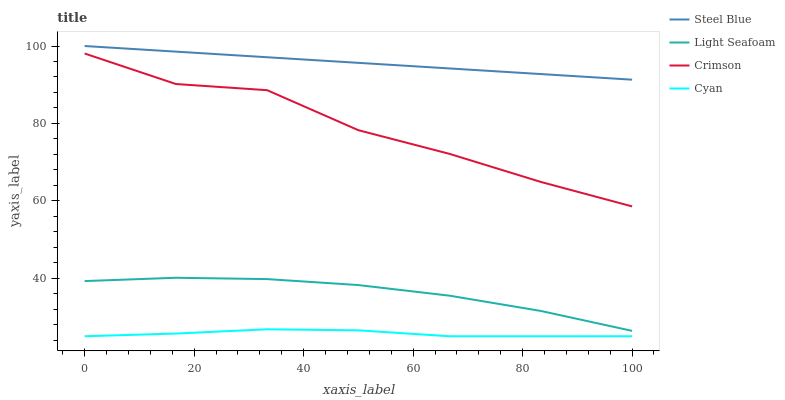Does Cyan have the minimum area under the curve?
Answer yes or no. Yes. Does Steel Blue have the maximum area under the curve?
Answer yes or no. Yes. Does Light Seafoam have the minimum area under the curve?
Answer yes or no. No. Does Light Seafoam have the maximum area under the curve?
Answer yes or no. No. Is Steel Blue the smoothest?
Answer yes or no. Yes. Is Crimson the roughest?
Answer yes or no. Yes. Is Cyan the smoothest?
Answer yes or no. No. Is Cyan the roughest?
Answer yes or no. No. Does Cyan have the lowest value?
Answer yes or no. Yes. Does Light Seafoam have the lowest value?
Answer yes or no. No. Does Steel Blue have the highest value?
Answer yes or no. Yes. Does Light Seafoam have the highest value?
Answer yes or no. No. Is Light Seafoam less than Steel Blue?
Answer yes or no. Yes. Is Crimson greater than Cyan?
Answer yes or no. Yes. Does Light Seafoam intersect Steel Blue?
Answer yes or no. No. 